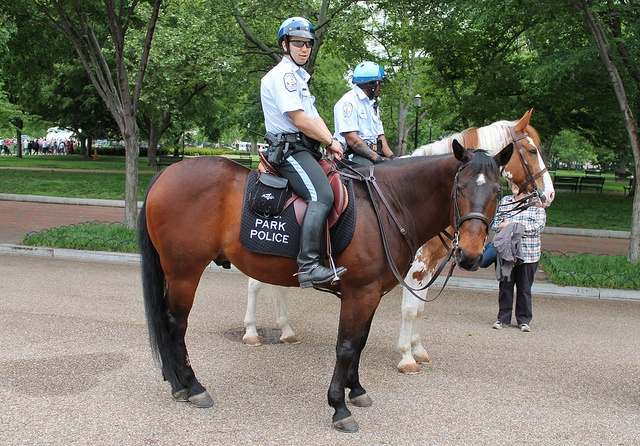Describe the objects in this image and their specific colors. I can see horse in black, maroon, gray, and brown tones, people in black, white, and gray tones, horse in black, lightgray, darkgray, gray, and tan tones, people in black, darkgray, gray, and lightgray tones, and people in black, white, gray, and lightblue tones in this image. 